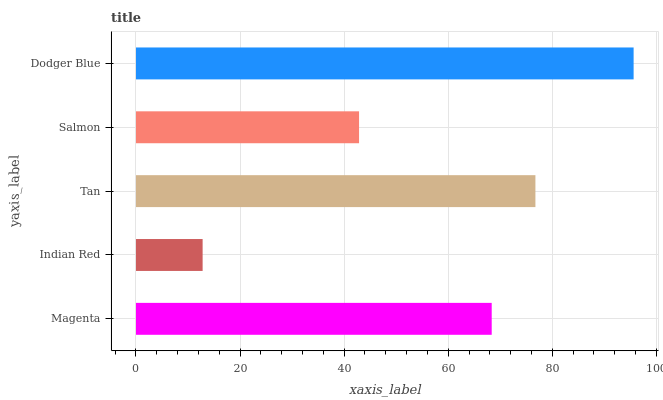Is Indian Red the minimum?
Answer yes or no. Yes. Is Dodger Blue the maximum?
Answer yes or no. Yes. Is Tan the minimum?
Answer yes or no. No. Is Tan the maximum?
Answer yes or no. No. Is Tan greater than Indian Red?
Answer yes or no. Yes. Is Indian Red less than Tan?
Answer yes or no. Yes. Is Indian Red greater than Tan?
Answer yes or no. No. Is Tan less than Indian Red?
Answer yes or no. No. Is Magenta the high median?
Answer yes or no. Yes. Is Magenta the low median?
Answer yes or no. Yes. Is Salmon the high median?
Answer yes or no. No. Is Dodger Blue the low median?
Answer yes or no. No. 